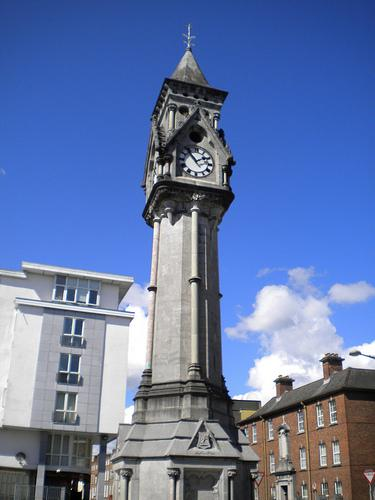Question: when was the monument photographed?
Choices:
A. Before noon.
B. Early afternoon.
C. The daytime.
D. Noon.
Answer with the letter. Answer: C Question: what is in the sky of the picture?
Choices:
A. The sun.
B. Clouds.
C. Water vapor.
D. Birds.
Answer with the letter. Answer: B Question: how is the weather in the picture?
Choices:
A. Temperate.
B. Calm.
C. Clear.
D. Nice.
Answer with the letter. Answer: C Question: what is on the monument?
Choices:
A. Clock.
B. A time piece.
C. A sundial.
D. A circle.
Answer with the letter. Answer: A Question: what is in the picture?
Choices:
A. A bank.
B. The capital house.
C. A monument and buildings.
D. A shopping plaza.
Answer with the letter. Answer: C 